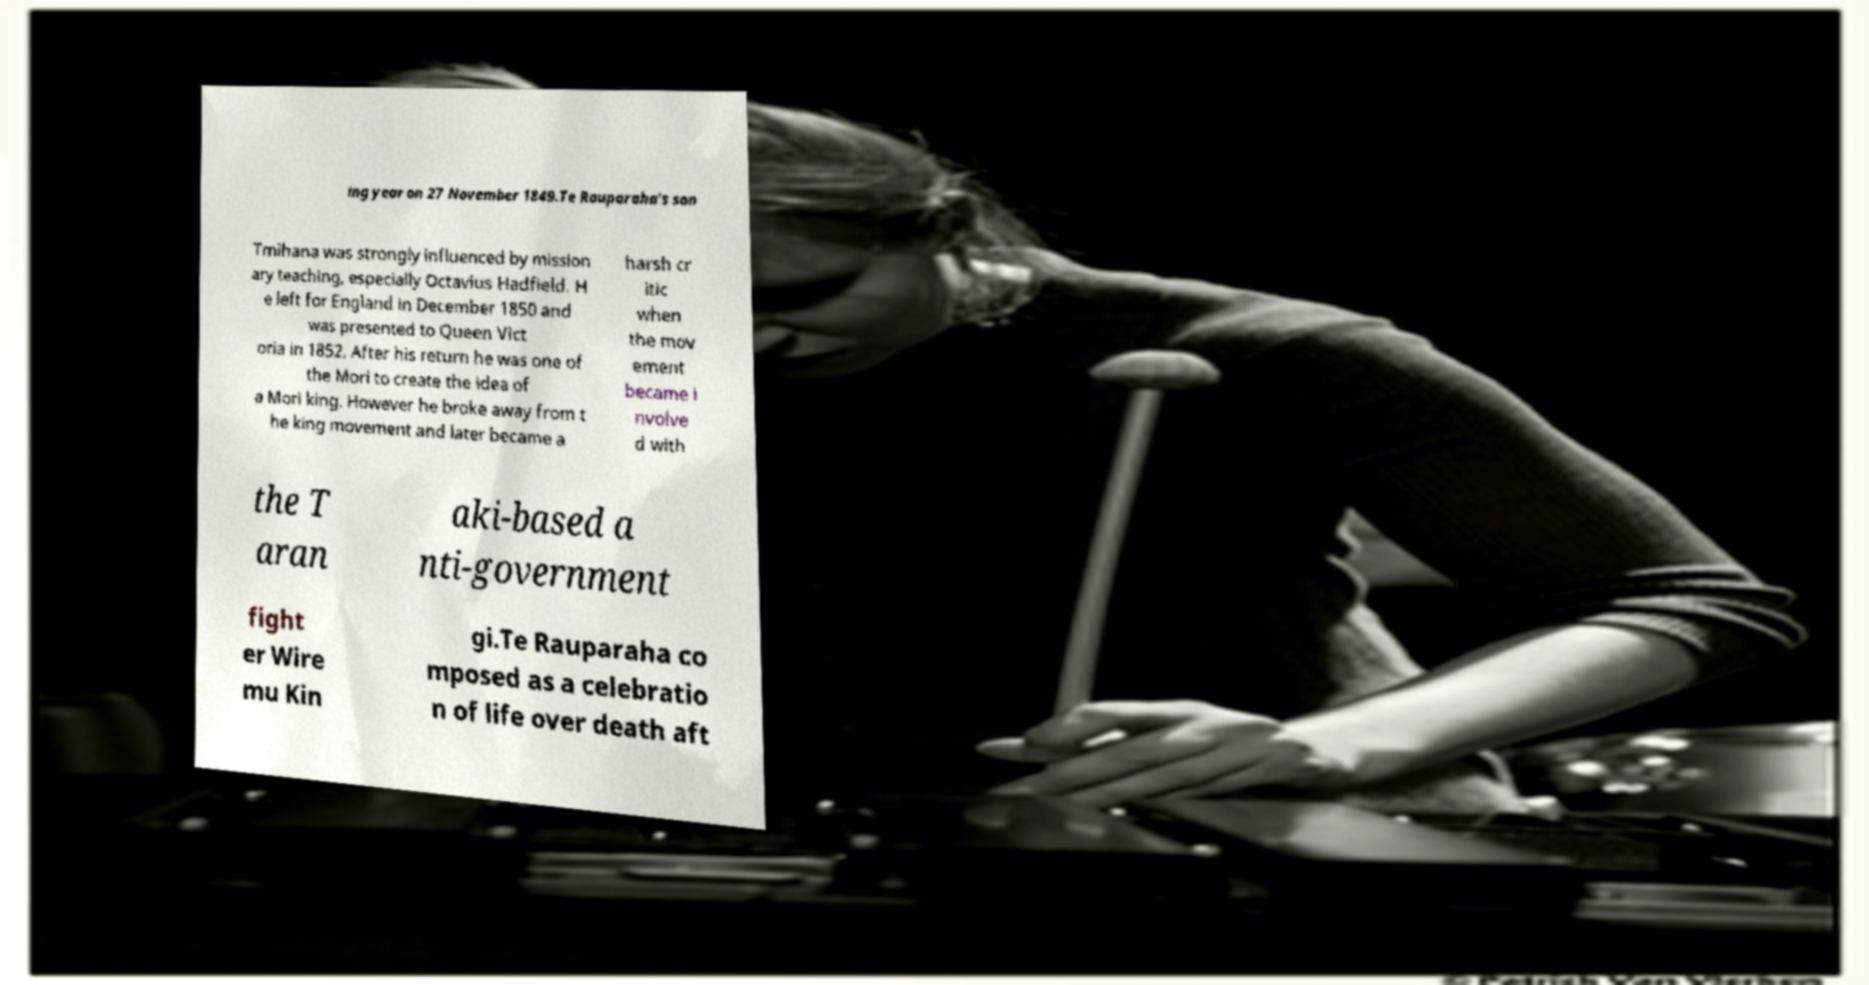For documentation purposes, I need the text within this image transcribed. Could you provide that? ing year on 27 November 1849.Te Rauparaha's son Tmihana was strongly influenced by mission ary teaching, especially Octavius Hadfield. H e left for England in December 1850 and was presented to Queen Vict oria in 1852. After his return he was one of the Mori to create the idea of a Mori king. However he broke away from t he king movement and later became a harsh cr itic when the mov ement became i nvolve d with the T aran aki-based a nti-government fight er Wire mu Kin gi.Te Rauparaha co mposed as a celebratio n of life over death aft 